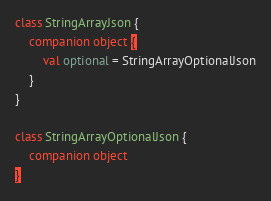<code> <loc_0><loc_0><loc_500><loc_500><_Kotlin_>class StringArrayJson {
    companion object {
        val optional = StringArrayOptionalJson
    }
}

class StringArrayOptionalJson {
    companion object
}</code> 